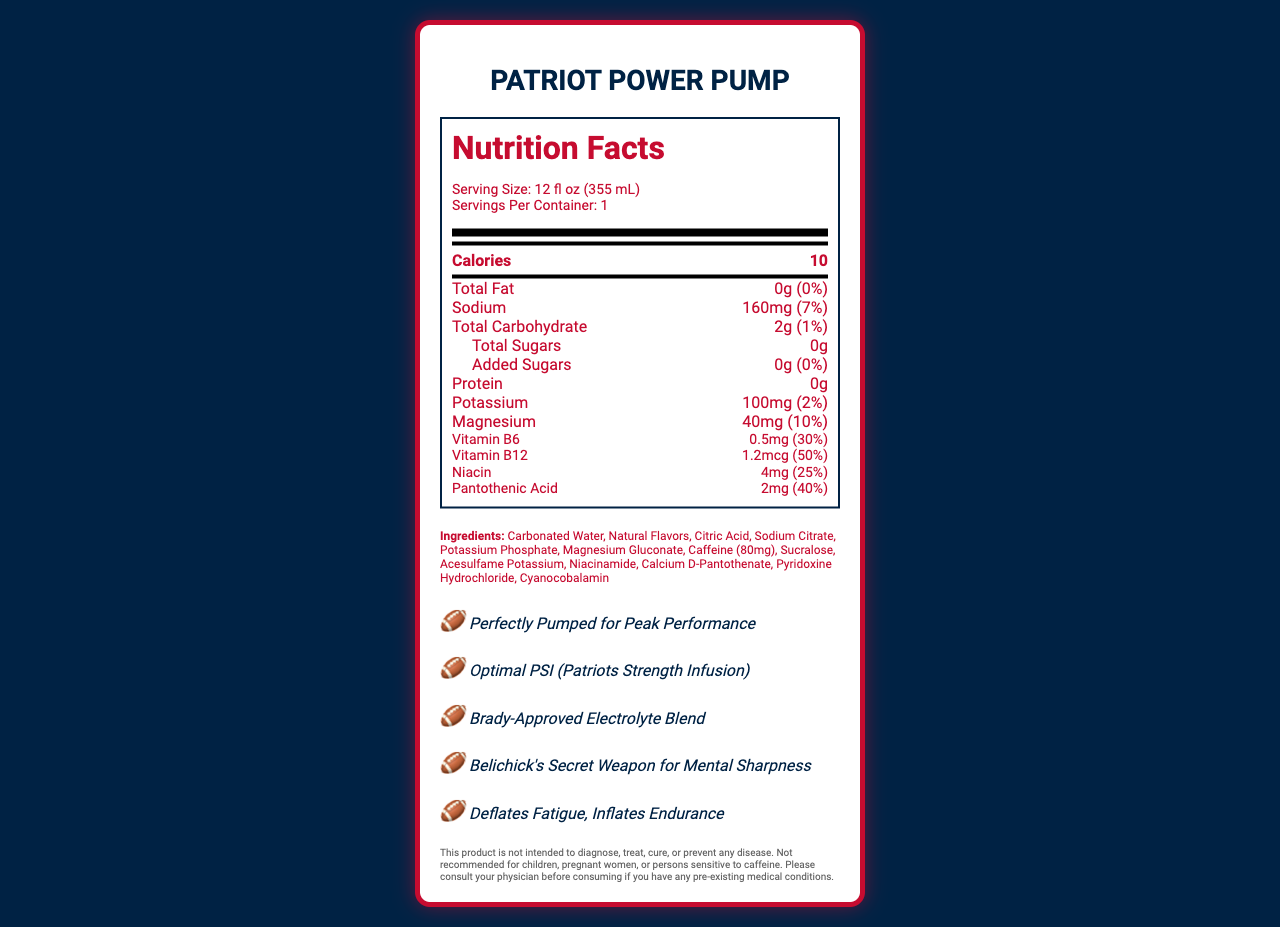what is the serving size of Patriot Power Pump? The serving size is clearly mentioned under the serving information section as 12 fl oz (355 mL).
Answer: 12 fl oz (355 mL) how many calories are in one serving of Patriot Power Pump? The number of calories per serving is explicitly stated in the main nutrient section as 10.
Answer: 10 what is the amount of sodium in Patriot Power Pump and its daily value percentage? The sodium amount is listed as 160mg with a daily value of 7% in the nutrient section.
Answer: 160mg, 7% list the vitamins present in Patriot Power Pump along with their daily values. These vitamins and their daily values are listed in the vitamins section in the document.
Answer: Vitamin B6: 0.5mg (30%), Vitamin B12: 1.2mcg (50%), Niacin: 4mg (25%), Pantothenic Acid: 2mg (40%) what are the marketing claims made for Patriot Power Pump? The marketing claims are provided in the marketing claims section, each claim being explicitly listed.
Answer: Perfectly Pumped for Peak Performance, Optimal PSI (Patriots Strength Infusion), Brady-Approved Electrolyte Blend, Belichick's Secret Weapon for Mental Sharpness, Deflates Fatigue, Inflates Endurance how much caffeine does Patriot Power Pump contain? A. 40mg B. 80mg C. 100mg D. 120mg The amount of caffeine is provided in the ingredients list as 80mg.
Answer: B. 80mg what percentage of daily value for magnesium does Patriot Power Pump provide? A. 2% B. 7% C. 10% D. 30% The document states that magnesium is present in an amount that covers 10% of the daily value.
Answer: C. 10% does the drink contain any added sugars? The document clearly states that there are 0g of total sugars and 0g of added sugars with 0% daily value.
Answer: No should children consume Patriot Power Pump? The legal disclaimer advises that the product is not recommended for children.
Answer: No summarize the main features of Patriot Power Pump. The summary includes essential details such as nutrient content, marketing claims, serving info, and allergen warnings.
Answer: Patriot Power Pump is a low-calorie, low-carb energy drink with a variety of electrolytes and vitamins like potassium, magnesium, and B-vitamins. It has 160mg of sodium and 80mg of caffeine per 12 fl oz serving. Marketing claims suggest it enhances performance, endurance, and mental sharpness. Additionally, it's produced in a facility that processes common allergens like milk, soy, and tree nuts. how many grams of protein are in Patriot Power Pump? The nutrient section lists protein content as 0g.
Answer: 0g is there calcium in Patriot Power Pump? The document does not mention calcium in the nutrient or ingredients sections.
Answer: Not enough information which electrolyte in Patriot Power Pump has the lowest daily value percentage? The nutrient section shows that potassium has the lowest daily value of 2% compared to sodium and magnesium.
Answer: Potassium: 2% 